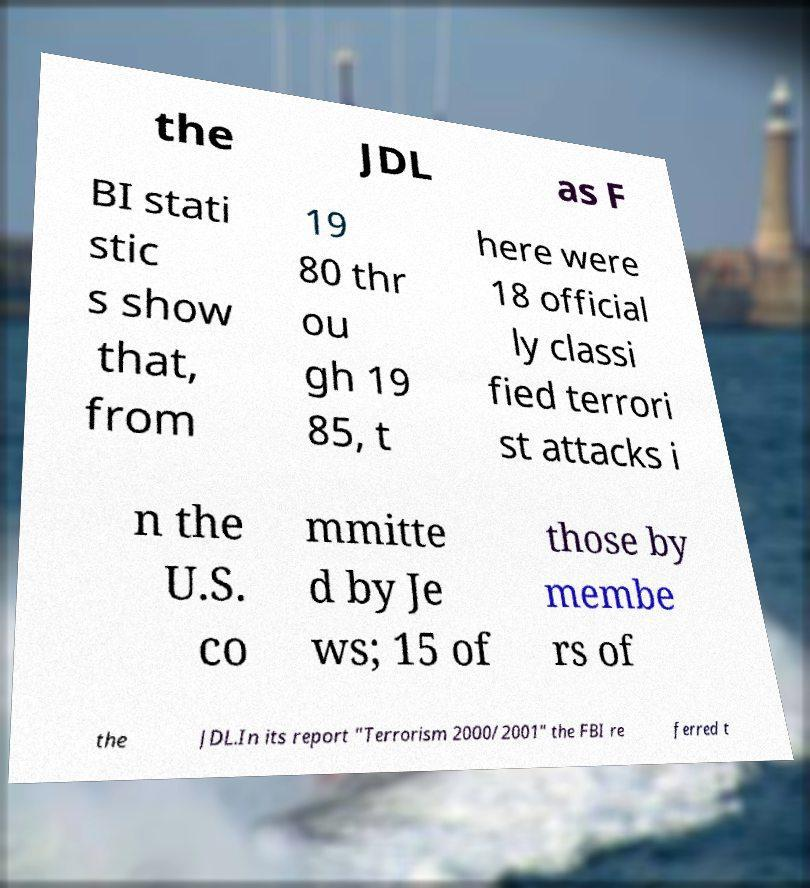Please read and relay the text visible in this image. What does it say? the JDL as F BI stati stic s show that, from 19 80 thr ou gh 19 85, t here were 18 official ly classi fied terrori st attacks i n the U.S. co mmitte d by Je ws; 15 of those by membe rs of the JDL.In its report "Terrorism 2000/2001" the FBI re ferred t 